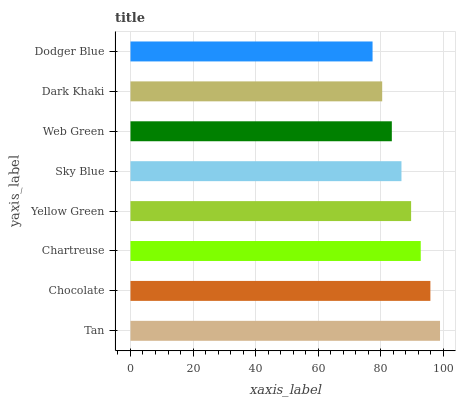Is Dodger Blue the minimum?
Answer yes or no. Yes. Is Tan the maximum?
Answer yes or no. Yes. Is Chocolate the minimum?
Answer yes or no. No. Is Chocolate the maximum?
Answer yes or no. No. Is Tan greater than Chocolate?
Answer yes or no. Yes. Is Chocolate less than Tan?
Answer yes or no. Yes. Is Chocolate greater than Tan?
Answer yes or no. No. Is Tan less than Chocolate?
Answer yes or no. No. Is Yellow Green the high median?
Answer yes or no. Yes. Is Sky Blue the low median?
Answer yes or no. Yes. Is Chartreuse the high median?
Answer yes or no. No. Is Chartreuse the low median?
Answer yes or no. No. 